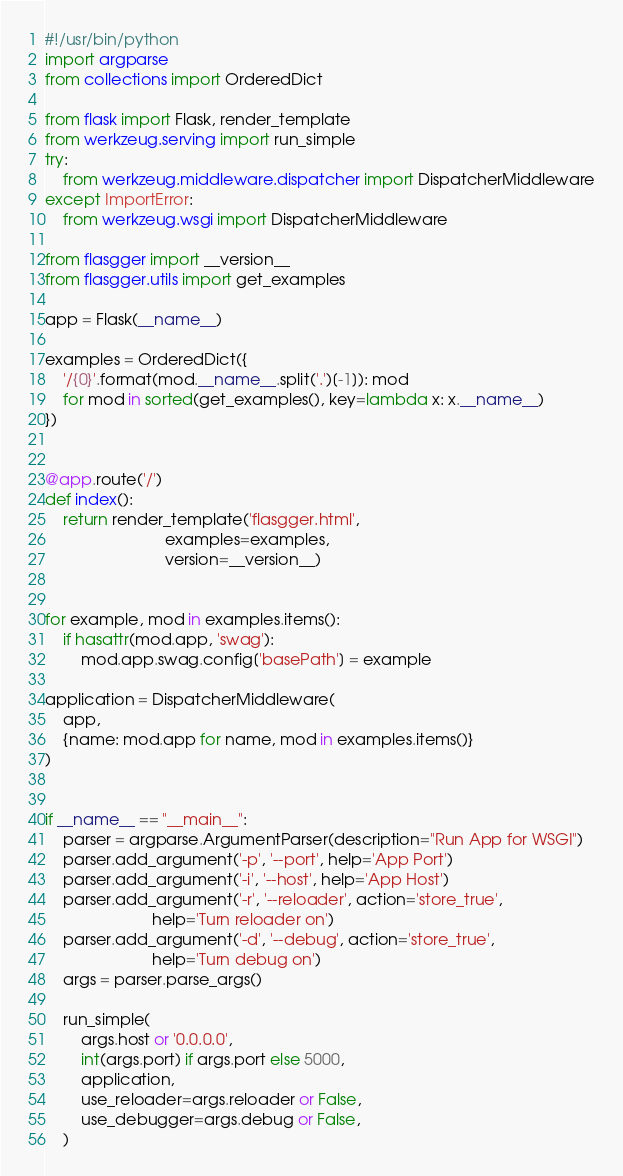Convert code to text. <code><loc_0><loc_0><loc_500><loc_500><_Python_>#!/usr/bin/python
import argparse
from collections import OrderedDict

from flask import Flask, render_template
from werkzeug.serving import run_simple
try:
    from werkzeug.middleware.dispatcher import DispatcherMiddleware
except ImportError:
    from werkzeug.wsgi import DispatcherMiddleware

from flasgger import __version__
from flasgger.utils import get_examples

app = Flask(__name__)

examples = OrderedDict({
    '/{0}'.format(mod.__name__.split('.')[-1]): mod
    for mod in sorted(get_examples(), key=lambda x: x.__name__)
})


@app.route('/')
def index():
    return render_template('flasgger.html',
                           examples=examples,
                           version=__version__)


for example, mod in examples.items():
    if hasattr(mod.app, 'swag'):
        mod.app.swag.config['basePath'] = example

application = DispatcherMiddleware(
    app,
    {name: mod.app for name, mod in examples.items()}
)


if __name__ == "__main__":
    parser = argparse.ArgumentParser(description="Run App for WSGI")
    parser.add_argument('-p', '--port', help='App Port')
    parser.add_argument('-i', '--host', help='App Host')
    parser.add_argument('-r', '--reloader', action='store_true',
                        help='Turn reloader on')
    parser.add_argument('-d', '--debug', action='store_true',
                        help='Turn debug on')
    args = parser.parse_args()

    run_simple(
        args.host or '0.0.0.0',
        int(args.port) if args.port else 5000,
        application,
        use_reloader=args.reloader or False,
        use_debugger=args.debug or False,
    )
</code> 